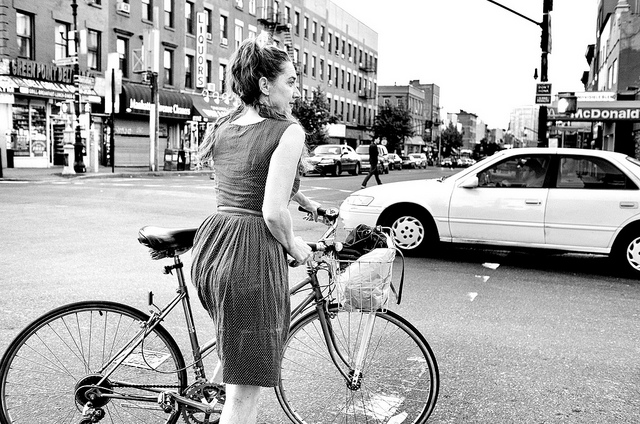<image>Is the woman in the picture having a bad day? I am not sure if the woman in the picture is having a bad day. Is the woman in the picture having a bad day? I don't know if the woman in the picture is having a bad day. Based on the answers, it seems that she is not. 